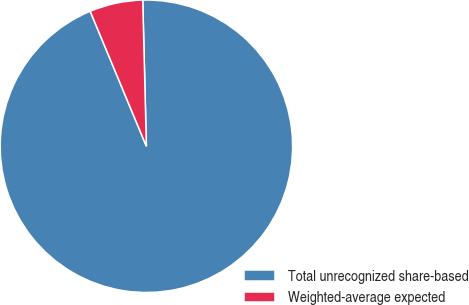<chart> <loc_0><loc_0><loc_500><loc_500><pie_chart><fcel>Total unrecognized share-based<fcel>Weighted-average expected<nl><fcel>94.12%<fcel>5.88%<nl></chart> 